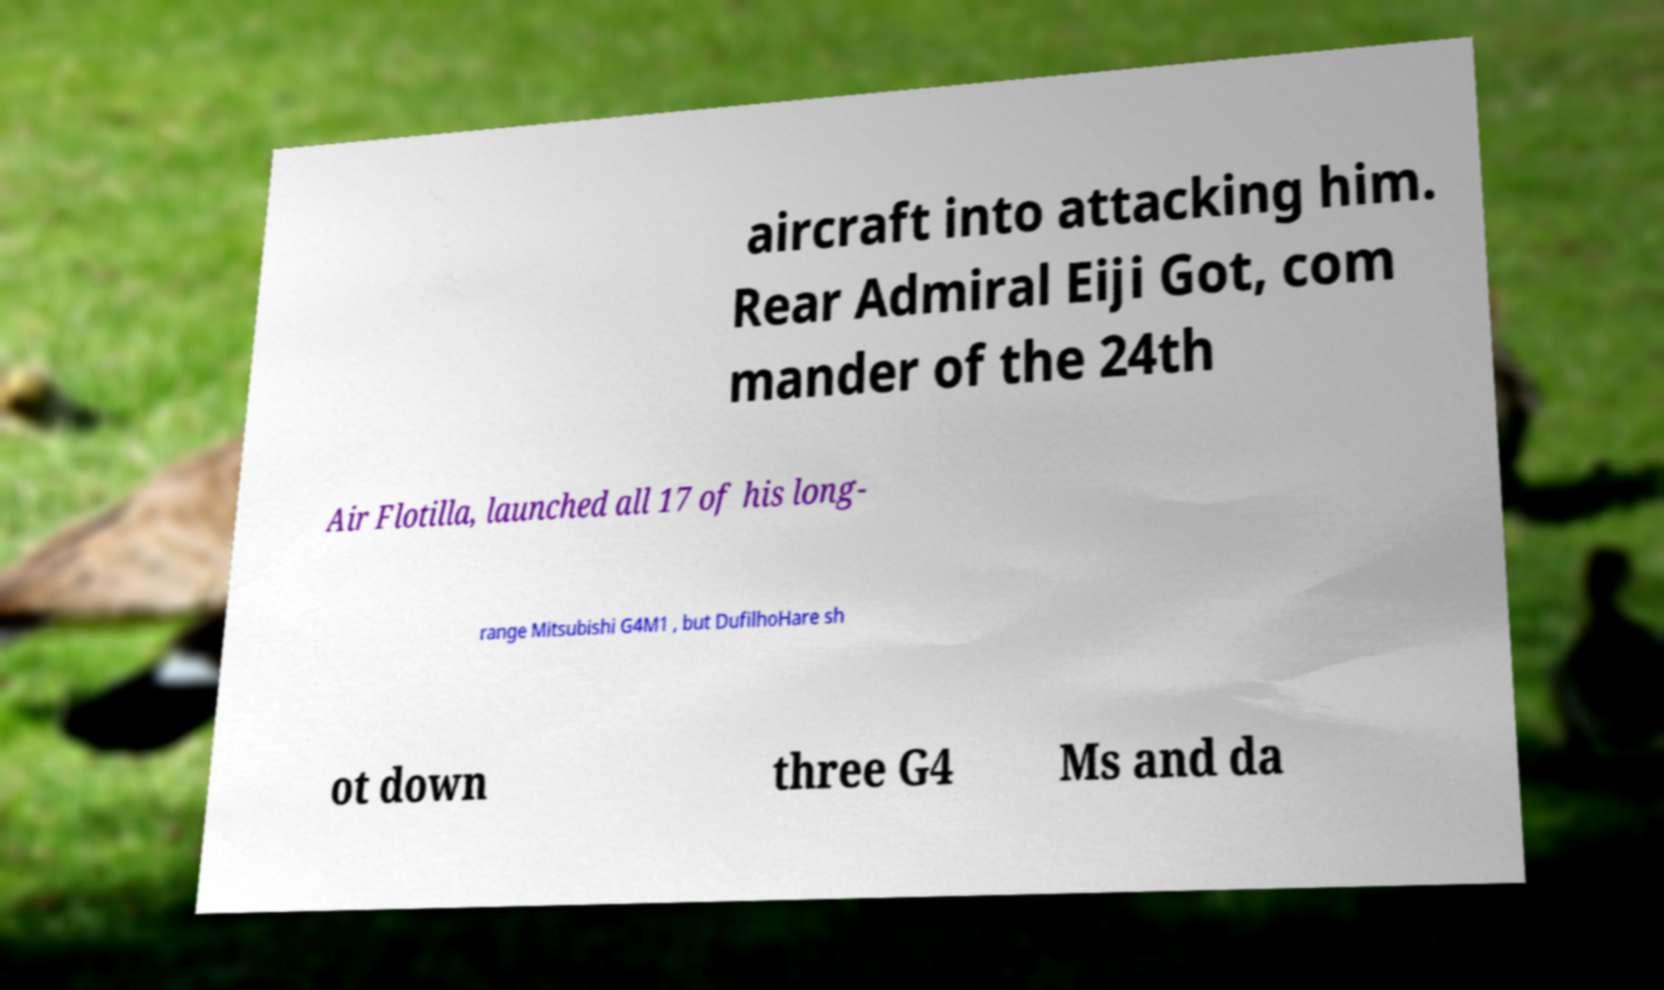For documentation purposes, I need the text within this image transcribed. Could you provide that? aircraft into attacking him. Rear Admiral Eiji Got, com mander of the 24th Air Flotilla, launched all 17 of his long- range Mitsubishi G4M1 , but DufilhoHare sh ot down three G4 Ms and da 